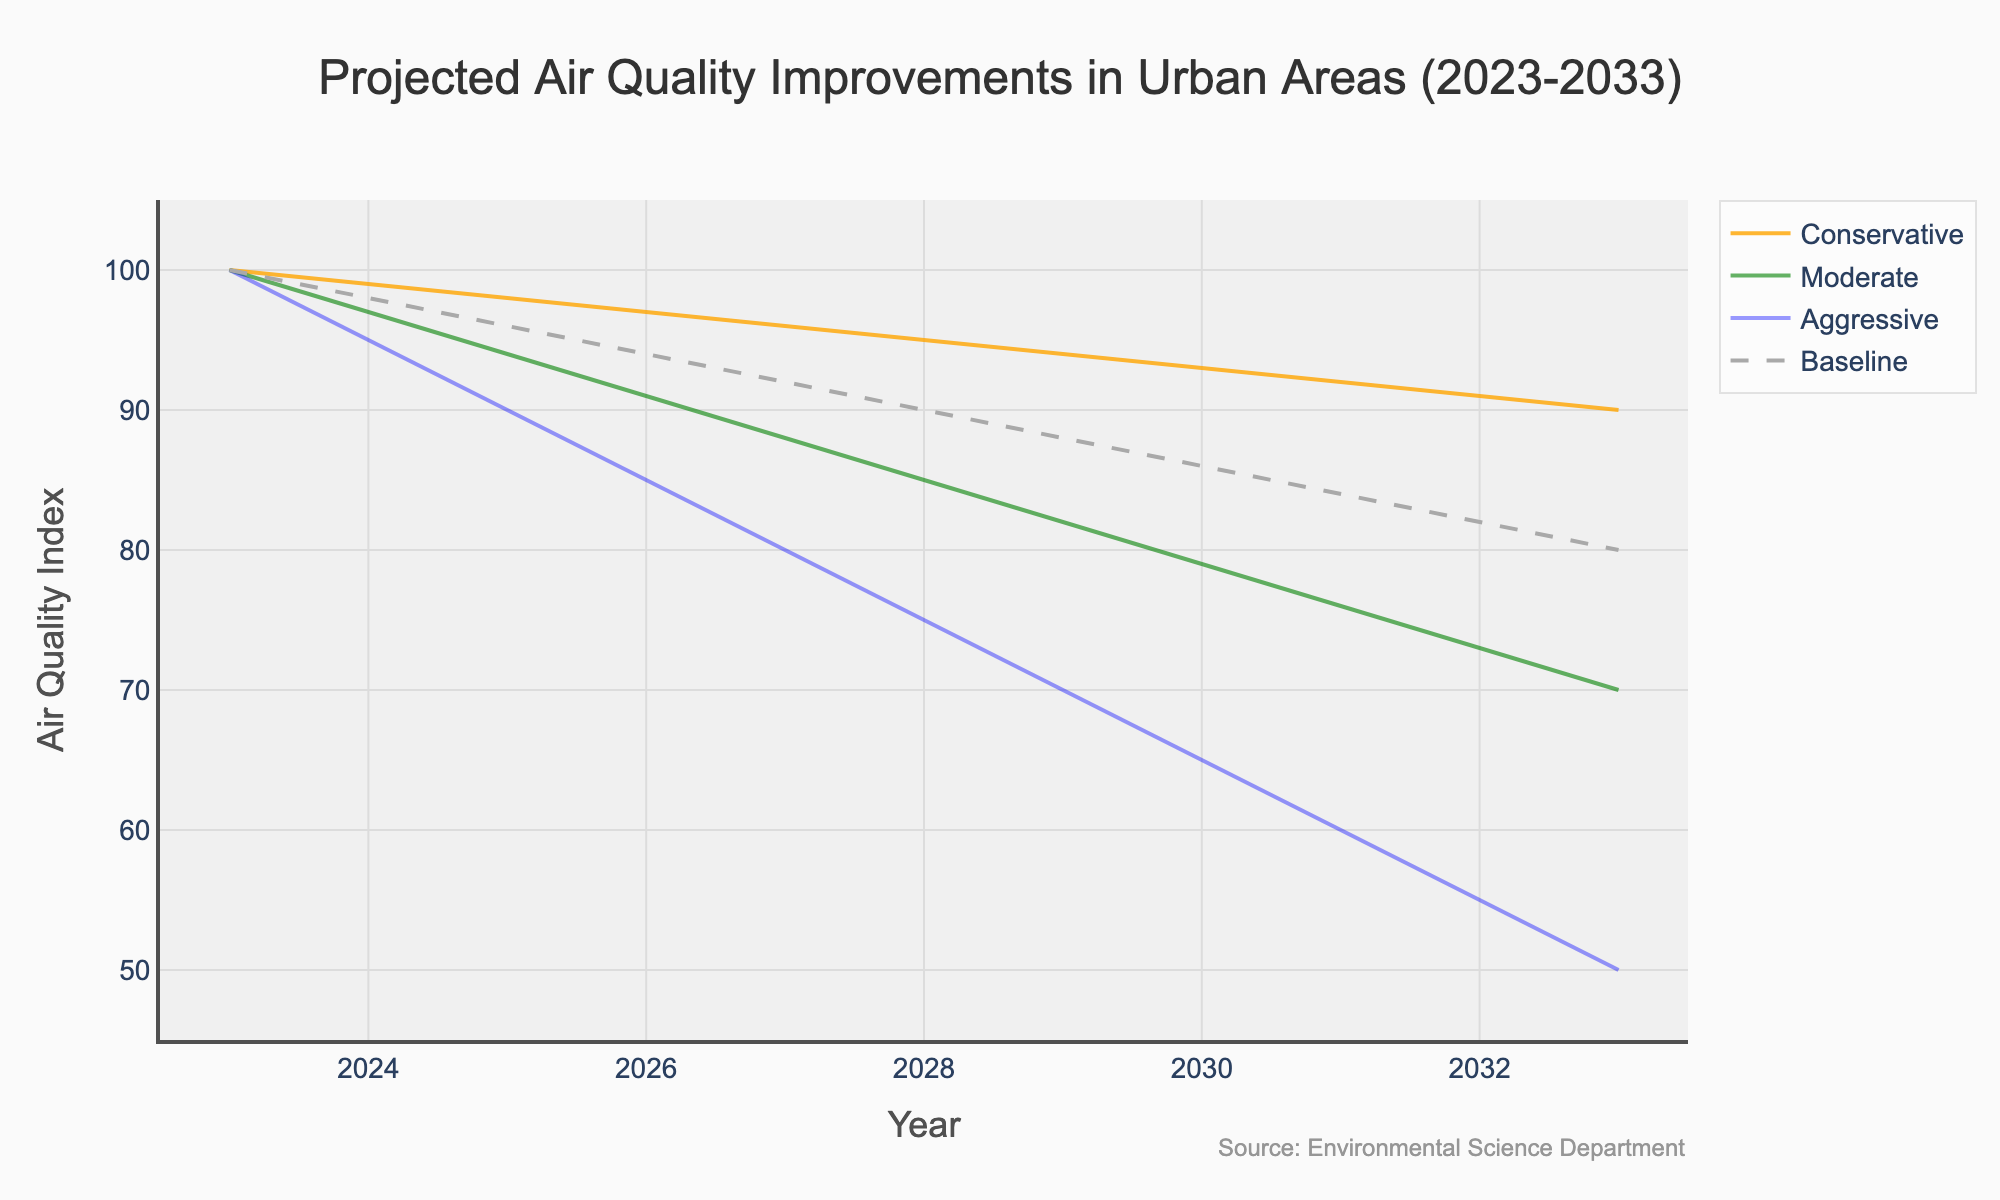What is the title of the chart? The title of the chart is generally located at the top and provides a brief summary of the displayed data. Looking at the top of the chart, the title reads "Projected Air Quality Improvements in Urban Areas (2023-2033)"
Answer: Projected Air Quality Improvements in Urban Areas (2023-2033) What does the baseline line represent and how is it styled? The baseline line typically represents a reference or starting point for the data. In this chart, the line is styled with a dashed pattern and is grey in color, indicating it is not one of the active pollution control scenarios but serves as a reference.
Answer: It represents the current air quality levels without any improvements and is displayed with a grey dashed line In what year do the "Aggressive" and "Moderate" scenarios start to significantly diverge? By examining where the lines representing the "Aggressive" and "Moderate" scenarios move apart substantially, we can identify the year. They start diverging significantly around 2026.
Answer: 2026 Which scenario shows the steepest decline in air quality index over the next decade and how can you tell? The scenario with the steepest decline will have the line that drops the quickest over the year range. Looking at the chart, the "Aggressive" scenario has the most pronounced decline, showing the greatest decrease from 100 to 50 over ten years.
Answer: Aggressive By how much is the air quality index expected to improve under the "Moderate" scenario from 2023 to 2033? To determine the improvement, subtract the 2033 value of the "Moderate" scenario from the 2023 value. The index starts at 100 in 2023 and goes down to 70 in 2033. Therefore, the improvement is 100 - 70 = 30.
Answer: 30 Compare the air quality index under the "Conservative" scenario in 2028 with the "Aggressive" scenario in 2028. Which is higher and by how much? Identify the values for the "Conservative" and "Aggressive" scenarios in 2028 from the chart. The "Conservative" scenario is at 95 and the "Aggressive" scenario is at 75. The "Conservative" scenario is higher by 95 - 75 = 20.
Answer: Conservative by 20 How does the air quality index change under the "Conservative" scenario from 2023 to 2024? To find the change, subtract the value in 2024 from the value in 2023 for the "Conservative" scenario. It changes from 100 to 99, thus the change is 100 - 99 = 1.
Answer: Decreases by 1 What is the air quality index value for the "Aggressive" scenario in 2032? Locate the data point for the "Aggressive" scenario in the year 2032. According to the chart, the air quality index value for "Aggressive" in 2032 is 55.
Answer: 55 If an urban area follows the "Moderate" scenario, what is the predicted air quality index in 2029 and how does it compare to the baseline in the same year? Look up the values for the "Moderate" scenario and the baseline for the year 2029 on the chart. The "Moderate" scenario predicts an index of 82, while the baseline is at 88. The "Moderate" scenario is 88 - 82 = 6 points lower than the baseline.
Answer: 82, 6 points lower than baseline What is the source of the data used in the chart? The source of the data is typically indicated in a note or annotation near the bottom or corners of the chart. According to the annotation on the chart, the source is "Environmental Science Department".
Answer: Environmental Science Department 